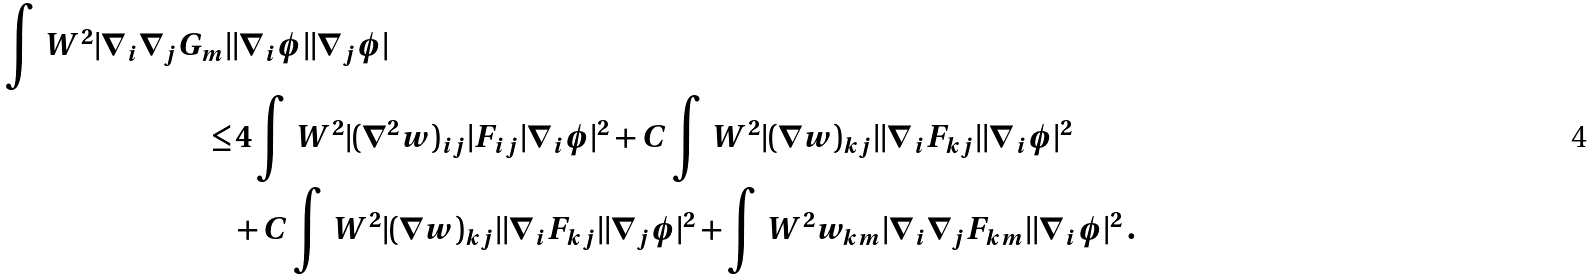Convert formula to latex. <formula><loc_0><loc_0><loc_500><loc_500>\int \, W ^ { 2 } | \nabla _ { i } \nabla _ { j } G _ { m } | & | \nabla _ { i } \phi | | \nabla _ { j } \phi | \\ \leq & \, 4 \int \, W ^ { 2 } | ( \nabla ^ { 2 } w ) _ { i j } | F _ { i j } | \nabla _ { i } \phi | ^ { 2 } + C \int \, W ^ { 2 } | ( \nabla w ) _ { k j } | | \nabla _ { i } F _ { k j } | | \nabla _ { i } \phi | ^ { 2 } \\ & + C \int \, W ^ { 2 } | ( \nabla w ) _ { k j } | | \nabla _ { i } F _ { k j } | | \nabla _ { j } \phi | ^ { 2 } + \int \, W ^ { 2 } w _ { k m } | \nabla _ { i } \nabla _ { j } F _ { k m } | | \nabla _ { i } \phi | ^ { 2 } \, .</formula> 